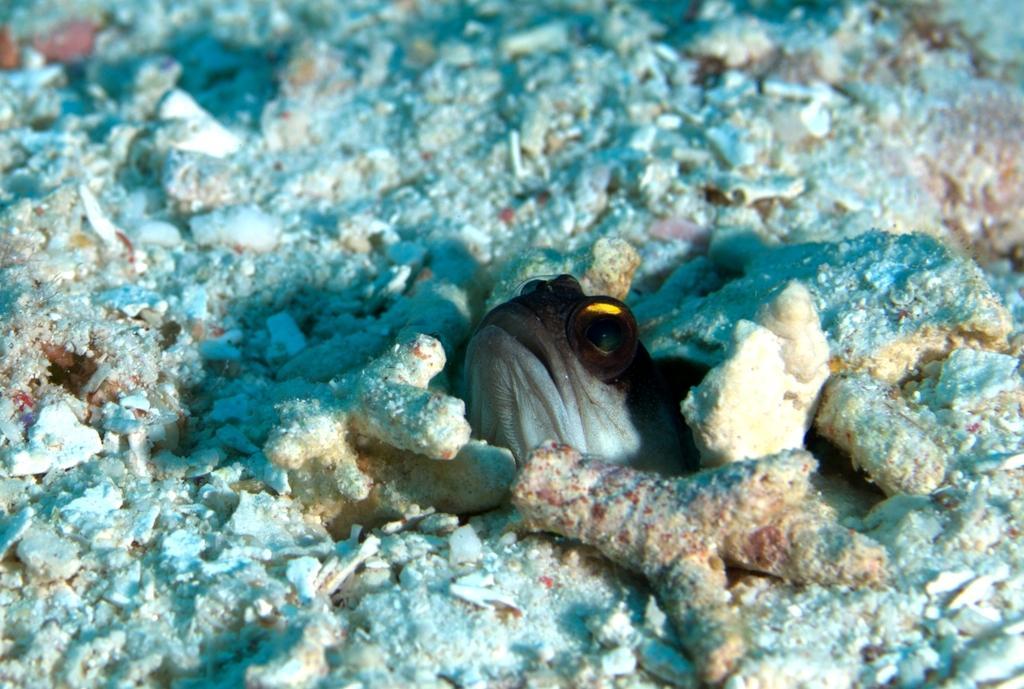Please provide a concise description of this image. In this image, this looks like a fish. I think these are the corals. 